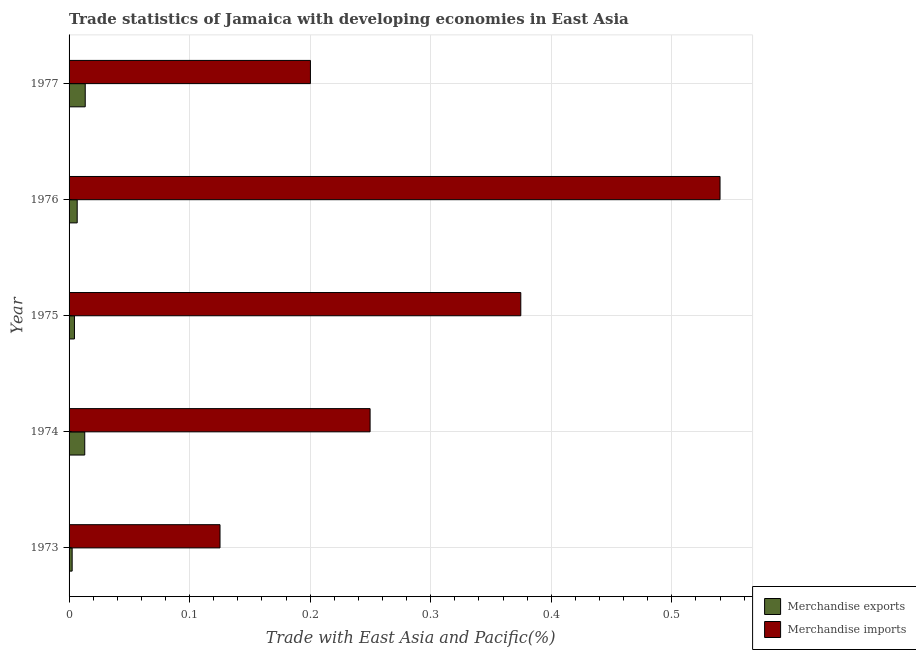How many groups of bars are there?
Provide a short and direct response. 5. Are the number of bars on each tick of the Y-axis equal?
Your answer should be compact. Yes. What is the label of the 2nd group of bars from the top?
Your answer should be very brief. 1976. What is the merchandise imports in 1977?
Offer a terse response. 0.2. Across all years, what is the maximum merchandise exports?
Your response must be concise. 0.01. Across all years, what is the minimum merchandise exports?
Offer a terse response. 0. In which year was the merchandise imports maximum?
Give a very brief answer. 1976. In which year was the merchandise imports minimum?
Ensure brevity in your answer.  1973. What is the total merchandise exports in the graph?
Make the answer very short. 0.04. What is the difference between the merchandise exports in 1975 and that in 1976?
Ensure brevity in your answer.  -0. What is the difference between the merchandise exports in 1974 and the merchandise imports in 1977?
Give a very brief answer. -0.19. What is the average merchandise imports per year?
Offer a terse response. 0.3. In the year 1973, what is the difference between the merchandise imports and merchandise exports?
Offer a very short reply. 0.12. What is the ratio of the merchandise exports in 1975 to that in 1977?
Your answer should be compact. 0.33. What is the difference between the highest and the second highest merchandise imports?
Provide a short and direct response. 0.17. What is the difference between the highest and the lowest merchandise exports?
Offer a terse response. 0.01. In how many years, is the merchandise exports greater than the average merchandise exports taken over all years?
Provide a succinct answer. 2. Is the sum of the merchandise exports in 1975 and 1977 greater than the maximum merchandise imports across all years?
Offer a very short reply. No. How many bars are there?
Your response must be concise. 10. What is the difference between two consecutive major ticks on the X-axis?
Provide a succinct answer. 0.1. Are the values on the major ticks of X-axis written in scientific E-notation?
Give a very brief answer. No. Does the graph contain grids?
Ensure brevity in your answer.  Yes. Where does the legend appear in the graph?
Your response must be concise. Bottom right. What is the title of the graph?
Your response must be concise. Trade statistics of Jamaica with developing economies in East Asia. Does "Electricity and heat production" appear as one of the legend labels in the graph?
Your answer should be compact. No. What is the label or title of the X-axis?
Your answer should be compact. Trade with East Asia and Pacific(%). What is the Trade with East Asia and Pacific(%) of Merchandise exports in 1973?
Provide a short and direct response. 0. What is the Trade with East Asia and Pacific(%) in Merchandise imports in 1973?
Your response must be concise. 0.13. What is the Trade with East Asia and Pacific(%) of Merchandise exports in 1974?
Provide a short and direct response. 0.01. What is the Trade with East Asia and Pacific(%) of Merchandise imports in 1974?
Your answer should be very brief. 0.25. What is the Trade with East Asia and Pacific(%) of Merchandise exports in 1975?
Your answer should be very brief. 0. What is the Trade with East Asia and Pacific(%) of Merchandise imports in 1975?
Provide a short and direct response. 0.37. What is the Trade with East Asia and Pacific(%) in Merchandise exports in 1976?
Keep it short and to the point. 0.01. What is the Trade with East Asia and Pacific(%) in Merchandise imports in 1976?
Offer a very short reply. 0.54. What is the Trade with East Asia and Pacific(%) of Merchandise exports in 1977?
Your response must be concise. 0.01. What is the Trade with East Asia and Pacific(%) of Merchandise imports in 1977?
Make the answer very short. 0.2. Across all years, what is the maximum Trade with East Asia and Pacific(%) of Merchandise exports?
Offer a very short reply. 0.01. Across all years, what is the maximum Trade with East Asia and Pacific(%) of Merchandise imports?
Provide a succinct answer. 0.54. Across all years, what is the minimum Trade with East Asia and Pacific(%) in Merchandise exports?
Your answer should be compact. 0. Across all years, what is the minimum Trade with East Asia and Pacific(%) in Merchandise imports?
Offer a very short reply. 0.13. What is the total Trade with East Asia and Pacific(%) in Merchandise exports in the graph?
Provide a short and direct response. 0.04. What is the total Trade with East Asia and Pacific(%) in Merchandise imports in the graph?
Your response must be concise. 1.49. What is the difference between the Trade with East Asia and Pacific(%) of Merchandise exports in 1973 and that in 1974?
Make the answer very short. -0.01. What is the difference between the Trade with East Asia and Pacific(%) in Merchandise imports in 1973 and that in 1974?
Make the answer very short. -0.12. What is the difference between the Trade with East Asia and Pacific(%) of Merchandise exports in 1973 and that in 1975?
Keep it short and to the point. -0. What is the difference between the Trade with East Asia and Pacific(%) of Merchandise imports in 1973 and that in 1975?
Provide a succinct answer. -0.25. What is the difference between the Trade with East Asia and Pacific(%) in Merchandise exports in 1973 and that in 1976?
Keep it short and to the point. -0. What is the difference between the Trade with East Asia and Pacific(%) in Merchandise imports in 1973 and that in 1976?
Ensure brevity in your answer.  -0.41. What is the difference between the Trade with East Asia and Pacific(%) of Merchandise exports in 1973 and that in 1977?
Your answer should be very brief. -0.01. What is the difference between the Trade with East Asia and Pacific(%) in Merchandise imports in 1973 and that in 1977?
Keep it short and to the point. -0.07. What is the difference between the Trade with East Asia and Pacific(%) of Merchandise exports in 1974 and that in 1975?
Make the answer very short. 0.01. What is the difference between the Trade with East Asia and Pacific(%) in Merchandise imports in 1974 and that in 1975?
Ensure brevity in your answer.  -0.12. What is the difference between the Trade with East Asia and Pacific(%) of Merchandise exports in 1974 and that in 1976?
Offer a very short reply. 0.01. What is the difference between the Trade with East Asia and Pacific(%) in Merchandise imports in 1974 and that in 1976?
Keep it short and to the point. -0.29. What is the difference between the Trade with East Asia and Pacific(%) in Merchandise exports in 1974 and that in 1977?
Offer a terse response. -0. What is the difference between the Trade with East Asia and Pacific(%) in Merchandise imports in 1974 and that in 1977?
Make the answer very short. 0.05. What is the difference between the Trade with East Asia and Pacific(%) of Merchandise exports in 1975 and that in 1976?
Your response must be concise. -0. What is the difference between the Trade with East Asia and Pacific(%) of Merchandise imports in 1975 and that in 1976?
Ensure brevity in your answer.  -0.17. What is the difference between the Trade with East Asia and Pacific(%) of Merchandise exports in 1975 and that in 1977?
Give a very brief answer. -0.01. What is the difference between the Trade with East Asia and Pacific(%) of Merchandise imports in 1975 and that in 1977?
Provide a succinct answer. 0.17. What is the difference between the Trade with East Asia and Pacific(%) of Merchandise exports in 1976 and that in 1977?
Give a very brief answer. -0.01. What is the difference between the Trade with East Asia and Pacific(%) in Merchandise imports in 1976 and that in 1977?
Offer a terse response. 0.34. What is the difference between the Trade with East Asia and Pacific(%) of Merchandise exports in 1973 and the Trade with East Asia and Pacific(%) of Merchandise imports in 1974?
Offer a very short reply. -0.25. What is the difference between the Trade with East Asia and Pacific(%) in Merchandise exports in 1973 and the Trade with East Asia and Pacific(%) in Merchandise imports in 1975?
Provide a succinct answer. -0.37. What is the difference between the Trade with East Asia and Pacific(%) of Merchandise exports in 1973 and the Trade with East Asia and Pacific(%) of Merchandise imports in 1976?
Offer a very short reply. -0.54. What is the difference between the Trade with East Asia and Pacific(%) of Merchandise exports in 1973 and the Trade with East Asia and Pacific(%) of Merchandise imports in 1977?
Provide a short and direct response. -0.2. What is the difference between the Trade with East Asia and Pacific(%) in Merchandise exports in 1974 and the Trade with East Asia and Pacific(%) in Merchandise imports in 1975?
Make the answer very short. -0.36. What is the difference between the Trade with East Asia and Pacific(%) in Merchandise exports in 1974 and the Trade with East Asia and Pacific(%) in Merchandise imports in 1976?
Offer a very short reply. -0.53. What is the difference between the Trade with East Asia and Pacific(%) of Merchandise exports in 1974 and the Trade with East Asia and Pacific(%) of Merchandise imports in 1977?
Keep it short and to the point. -0.19. What is the difference between the Trade with East Asia and Pacific(%) in Merchandise exports in 1975 and the Trade with East Asia and Pacific(%) in Merchandise imports in 1976?
Give a very brief answer. -0.54. What is the difference between the Trade with East Asia and Pacific(%) of Merchandise exports in 1975 and the Trade with East Asia and Pacific(%) of Merchandise imports in 1977?
Provide a short and direct response. -0.2. What is the difference between the Trade with East Asia and Pacific(%) of Merchandise exports in 1976 and the Trade with East Asia and Pacific(%) of Merchandise imports in 1977?
Ensure brevity in your answer.  -0.19. What is the average Trade with East Asia and Pacific(%) of Merchandise exports per year?
Your answer should be compact. 0.01. What is the average Trade with East Asia and Pacific(%) of Merchandise imports per year?
Offer a terse response. 0.3. In the year 1973, what is the difference between the Trade with East Asia and Pacific(%) in Merchandise exports and Trade with East Asia and Pacific(%) in Merchandise imports?
Ensure brevity in your answer.  -0.12. In the year 1974, what is the difference between the Trade with East Asia and Pacific(%) in Merchandise exports and Trade with East Asia and Pacific(%) in Merchandise imports?
Offer a very short reply. -0.24. In the year 1975, what is the difference between the Trade with East Asia and Pacific(%) of Merchandise exports and Trade with East Asia and Pacific(%) of Merchandise imports?
Provide a succinct answer. -0.37. In the year 1976, what is the difference between the Trade with East Asia and Pacific(%) in Merchandise exports and Trade with East Asia and Pacific(%) in Merchandise imports?
Offer a very short reply. -0.53. In the year 1977, what is the difference between the Trade with East Asia and Pacific(%) in Merchandise exports and Trade with East Asia and Pacific(%) in Merchandise imports?
Provide a short and direct response. -0.19. What is the ratio of the Trade with East Asia and Pacific(%) of Merchandise exports in 1973 to that in 1974?
Make the answer very short. 0.2. What is the ratio of the Trade with East Asia and Pacific(%) of Merchandise imports in 1973 to that in 1974?
Your response must be concise. 0.5. What is the ratio of the Trade with East Asia and Pacific(%) of Merchandise exports in 1973 to that in 1975?
Your answer should be very brief. 0.57. What is the ratio of the Trade with East Asia and Pacific(%) of Merchandise imports in 1973 to that in 1975?
Keep it short and to the point. 0.33. What is the ratio of the Trade with East Asia and Pacific(%) of Merchandise exports in 1973 to that in 1976?
Ensure brevity in your answer.  0.38. What is the ratio of the Trade with East Asia and Pacific(%) in Merchandise imports in 1973 to that in 1976?
Your answer should be very brief. 0.23. What is the ratio of the Trade with East Asia and Pacific(%) in Merchandise exports in 1973 to that in 1977?
Keep it short and to the point. 0.19. What is the ratio of the Trade with East Asia and Pacific(%) of Merchandise imports in 1973 to that in 1977?
Your response must be concise. 0.63. What is the ratio of the Trade with East Asia and Pacific(%) in Merchandise exports in 1974 to that in 1975?
Your response must be concise. 2.91. What is the ratio of the Trade with East Asia and Pacific(%) of Merchandise imports in 1974 to that in 1975?
Your response must be concise. 0.67. What is the ratio of the Trade with East Asia and Pacific(%) of Merchandise exports in 1974 to that in 1976?
Make the answer very short. 1.93. What is the ratio of the Trade with East Asia and Pacific(%) in Merchandise imports in 1974 to that in 1976?
Your answer should be compact. 0.46. What is the ratio of the Trade with East Asia and Pacific(%) in Merchandise exports in 1974 to that in 1977?
Offer a terse response. 0.97. What is the ratio of the Trade with East Asia and Pacific(%) of Merchandise imports in 1974 to that in 1977?
Offer a very short reply. 1.25. What is the ratio of the Trade with East Asia and Pacific(%) in Merchandise exports in 1975 to that in 1976?
Your answer should be very brief. 0.66. What is the ratio of the Trade with East Asia and Pacific(%) of Merchandise imports in 1975 to that in 1976?
Your response must be concise. 0.69. What is the ratio of the Trade with East Asia and Pacific(%) in Merchandise exports in 1975 to that in 1977?
Provide a succinct answer. 0.33. What is the ratio of the Trade with East Asia and Pacific(%) of Merchandise imports in 1975 to that in 1977?
Your response must be concise. 1.87. What is the ratio of the Trade with East Asia and Pacific(%) in Merchandise exports in 1976 to that in 1977?
Provide a succinct answer. 0.5. What is the ratio of the Trade with East Asia and Pacific(%) of Merchandise imports in 1976 to that in 1977?
Your answer should be compact. 2.7. What is the difference between the highest and the second highest Trade with East Asia and Pacific(%) in Merchandise imports?
Your answer should be compact. 0.17. What is the difference between the highest and the lowest Trade with East Asia and Pacific(%) in Merchandise exports?
Make the answer very short. 0.01. What is the difference between the highest and the lowest Trade with East Asia and Pacific(%) in Merchandise imports?
Your response must be concise. 0.41. 